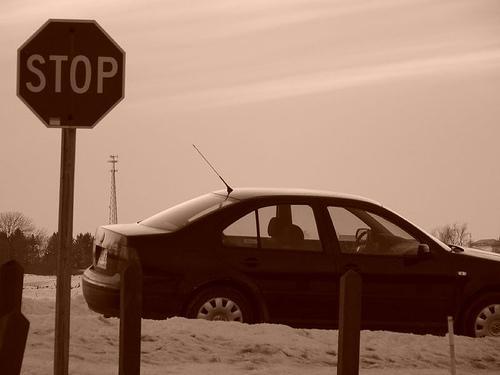How many people does it take to operate this vehicle?
Give a very brief answer. 1. 